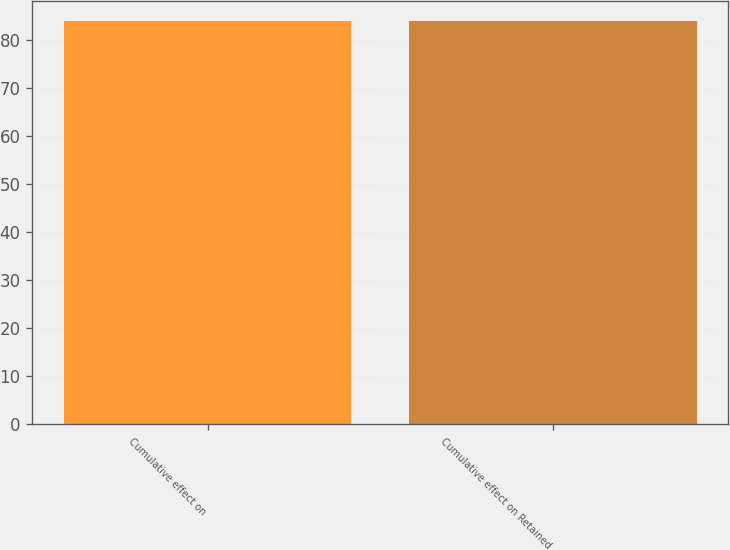<chart> <loc_0><loc_0><loc_500><loc_500><bar_chart><fcel>Cumulative effect on<fcel>Cumulative effect on Retained<nl><fcel>84<fcel>84.1<nl></chart> 